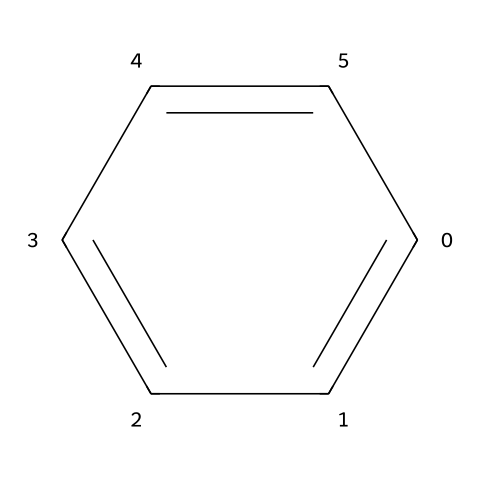What is the name of this chemical? The SMILES notation c1ccccc1 represents benzene, a colorless liquid with a sweet odor and is a fundamental building block in petrochemical industries.
Answer: benzene How many carbon atoms are in this molecule? The structure of benzene contains six carbon atoms, as evidenced by the six 'c' in the SMILES string.
Answer: six What type of bonding is present in this chemical? Benzene exhibits resonance, with alternating single and double bonds between carbon atoms, which is characteristic of aromatic compounds.
Answer: resonance What is the degree of saturation of this compound? The degree of saturation refers to the number of double bonds or rings in a molecule. Benzene has a fully saturated cyclic structure, resulting in a degree of saturation of six.
Answer: six How many hydrogen atoms are bonded to this molecule? Each of the six carbon atoms in benzene is bonded to one hydrogen atom, leading to a total of six hydrogen atoms in the molecule.
Answer: six What kind of hydrocarbon does benzene represent? Benzene is categorized as an aromatic hydrocarbon due to its stable ring structure with delocalized π electrons, which is a defining feature of aromaticity.
Answer: aromatic 